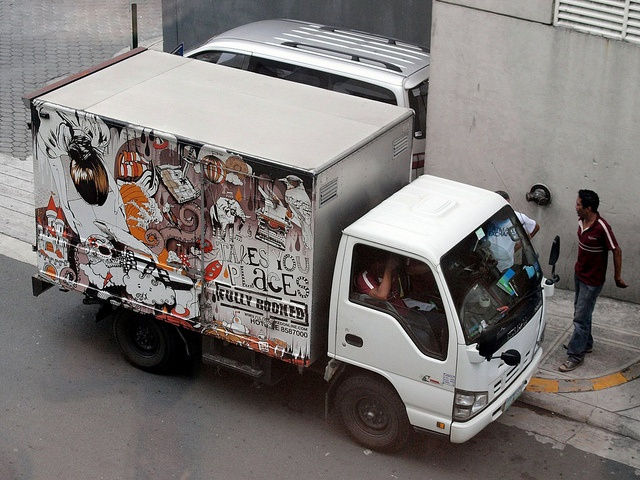Describe the objects in this image and their specific colors. I can see truck in darkgray, black, lightgray, and gray tones, car in darkgray, white, black, and gray tones, people in darkgray, black, gray, and maroon tones, people in darkgray, black, maroon, gray, and brown tones, and people in darkgray, gray, and black tones in this image. 